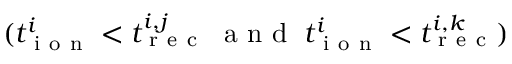<formula> <loc_0><loc_0><loc_500><loc_500>( t _ { i o n } ^ { i } < t _ { r e c } ^ { i , j } \, a n d \, t _ { i o n } ^ { i } < t _ { r e c } ^ { i , k } )</formula> 